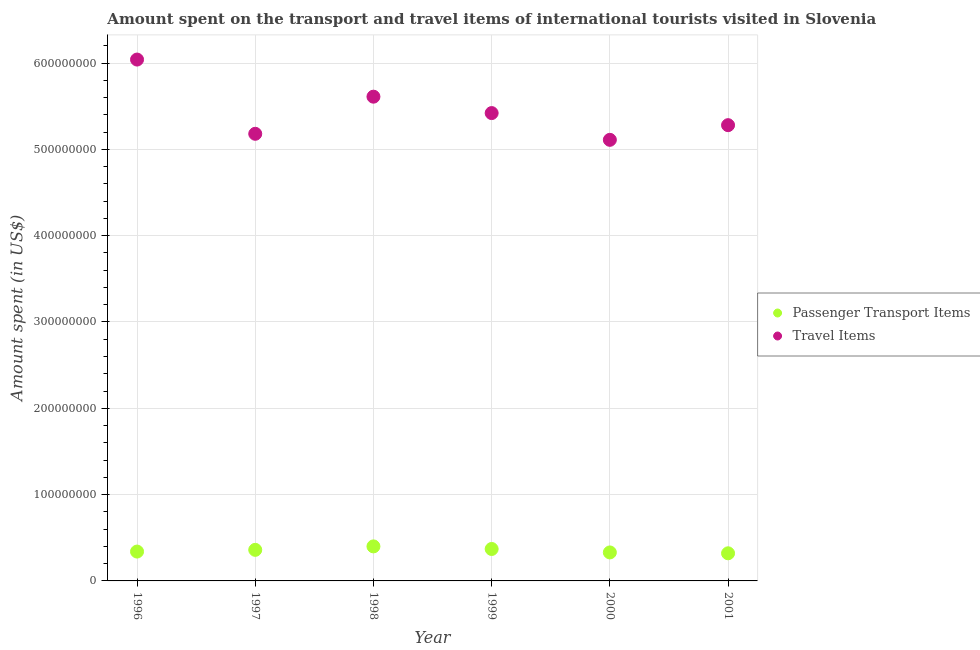How many different coloured dotlines are there?
Give a very brief answer. 2. What is the amount spent on passenger transport items in 1997?
Offer a very short reply. 3.60e+07. Across all years, what is the maximum amount spent on passenger transport items?
Provide a succinct answer. 4.00e+07. Across all years, what is the minimum amount spent in travel items?
Your response must be concise. 5.11e+08. In which year was the amount spent on passenger transport items minimum?
Give a very brief answer. 2001. What is the total amount spent on passenger transport items in the graph?
Offer a very short reply. 2.12e+08. What is the difference between the amount spent on passenger transport items in 1997 and that in 1999?
Give a very brief answer. -1.00e+06. What is the difference between the amount spent on passenger transport items in 2000 and the amount spent in travel items in 1996?
Your answer should be compact. -5.71e+08. What is the average amount spent in travel items per year?
Make the answer very short. 5.44e+08. In the year 1998, what is the difference between the amount spent on passenger transport items and amount spent in travel items?
Ensure brevity in your answer.  -5.21e+08. What is the ratio of the amount spent in travel items in 1999 to that in 2000?
Offer a terse response. 1.06. Is the amount spent in travel items in 1996 less than that in 2001?
Give a very brief answer. No. What is the difference between the highest and the second highest amount spent on passenger transport items?
Provide a succinct answer. 3.00e+06. What is the difference between the highest and the lowest amount spent on passenger transport items?
Provide a succinct answer. 8.00e+06. Is the sum of the amount spent on passenger transport items in 1997 and 1998 greater than the maximum amount spent in travel items across all years?
Keep it short and to the point. No. Is the amount spent in travel items strictly greater than the amount spent on passenger transport items over the years?
Provide a succinct answer. Yes. How many dotlines are there?
Give a very brief answer. 2. How many years are there in the graph?
Provide a short and direct response. 6. Are the values on the major ticks of Y-axis written in scientific E-notation?
Provide a succinct answer. No. Does the graph contain any zero values?
Provide a short and direct response. No. Does the graph contain grids?
Make the answer very short. Yes. Where does the legend appear in the graph?
Keep it short and to the point. Center right. What is the title of the graph?
Provide a short and direct response. Amount spent on the transport and travel items of international tourists visited in Slovenia. What is the label or title of the Y-axis?
Ensure brevity in your answer.  Amount spent (in US$). What is the Amount spent (in US$) in Passenger Transport Items in 1996?
Provide a succinct answer. 3.40e+07. What is the Amount spent (in US$) of Travel Items in 1996?
Provide a succinct answer. 6.04e+08. What is the Amount spent (in US$) of Passenger Transport Items in 1997?
Your answer should be compact. 3.60e+07. What is the Amount spent (in US$) in Travel Items in 1997?
Ensure brevity in your answer.  5.18e+08. What is the Amount spent (in US$) in Passenger Transport Items in 1998?
Make the answer very short. 4.00e+07. What is the Amount spent (in US$) of Travel Items in 1998?
Offer a very short reply. 5.61e+08. What is the Amount spent (in US$) in Passenger Transport Items in 1999?
Ensure brevity in your answer.  3.70e+07. What is the Amount spent (in US$) of Travel Items in 1999?
Give a very brief answer. 5.42e+08. What is the Amount spent (in US$) of Passenger Transport Items in 2000?
Your answer should be compact. 3.30e+07. What is the Amount spent (in US$) of Travel Items in 2000?
Offer a very short reply. 5.11e+08. What is the Amount spent (in US$) in Passenger Transport Items in 2001?
Keep it short and to the point. 3.20e+07. What is the Amount spent (in US$) of Travel Items in 2001?
Provide a succinct answer. 5.28e+08. Across all years, what is the maximum Amount spent (in US$) of Passenger Transport Items?
Make the answer very short. 4.00e+07. Across all years, what is the maximum Amount spent (in US$) in Travel Items?
Ensure brevity in your answer.  6.04e+08. Across all years, what is the minimum Amount spent (in US$) in Passenger Transport Items?
Provide a short and direct response. 3.20e+07. Across all years, what is the minimum Amount spent (in US$) in Travel Items?
Ensure brevity in your answer.  5.11e+08. What is the total Amount spent (in US$) in Passenger Transport Items in the graph?
Your answer should be compact. 2.12e+08. What is the total Amount spent (in US$) in Travel Items in the graph?
Provide a short and direct response. 3.26e+09. What is the difference between the Amount spent (in US$) of Travel Items in 1996 and that in 1997?
Offer a very short reply. 8.60e+07. What is the difference between the Amount spent (in US$) of Passenger Transport Items in 1996 and that in 1998?
Your answer should be compact. -6.00e+06. What is the difference between the Amount spent (in US$) of Travel Items in 1996 and that in 1998?
Your response must be concise. 4.30e+07. What is the difference between the Amount spent (in US$) in Passenger Transport Items in 1996 and that in 1999?
Offer a terse response. -3.00e+06. What is the difference between the Amount spent (in US$) in Travel Items in 1996 and that in 1999?
Your answer should be compact. 6.20e+07. What is the difference between the Amount spent (in US$) in Travel Items in 1996 and that in 2000?
Give a very brief answer. 9.30e+07. What is the difference between the Amount spent (in US$) in Travel Items in 1996 and that in 2001?
Provide a succinct answer. 7.60e+07. What is the difference between the Amount spent (in US$) of Passenger Transport Items in 1997 and that in 1998?
Your response must be concise. -4.00e+06. What is the difference between the Amount spent (in US$) in Travel Items in 1997 and that in 1998?
Provide a succinct answer. -4.30e+07. What is the difference between the Amount spent (in US$) in Travel Items in 1997 and that in 1999?
Make the answer very short. -2.40e+07. What is the difference between the Amount spent (in US$) of Passenger Transport Items in 1997 and that in 2000?
Ensure brevity in your answer.  3.00e+06. What is the difference between the Amount spent (in US$) of Travel Items in 1997 and that in 2000?
Your answer should be very brief. 7.00e+06. What is the difference between the Amount spent (in US$) of Passenger Transport Items in 1997 and that in 2001?
Your answer should be compact. 4.00e+06. What is the difference between the Amount spent (in US$) in Travel Items in 1997 and that in 2001?
Offer a terse response. -1.00e+07. What is the difference between the Amount spent (in US$) in Travel Items in 1998 and that in 1999?
Make the answer very short. 1.90e+07. What is the difference between the Amount spent (in US$) in Passenger Transport Items in 1998 and that in 2000?
Give a very brief answer. 7.00e+06. What is the difference between the Amount spent (in US$) in Travel Items in 1998 and that in 2000?
Give a very brief answer. 5.00e+07. What is the difference between the Amount spent (in US$) of Passenger Transport Items in 1998 and that in 2001?
Make the answer very short. 8.00e+06. What is the difference between the Amount spent (in US$) of Travel Items in 1998 and that in 2001?
Give a very brief answer. 3.30e+07. What is the difference between the Amount spent (in US$) of Travel Items in 1999 and that in 2000?
Ensure brevity in your answer.  3.10e+07. What is the difference between the Amount spent (in US$) in Travel Items in 1999 and that in 2001?
Ensure brevity in your answer.  1.40e+07. What is the difference between the Amount spent (in US$) in Passenger Transport Items in 2000 and that in 2001?
Offer a very short reply. 1.00e+06. What is the difference between the Amount spent (in US$) of Travel Items in 2000 and that in 2001?
Keep it short and to the point. -1.70e+07. What is the difference between the Amount spent (in US$) in Passenger Transport Items in 1996 and the Amount spent (in US$) in Travel Items in 1997?
Keep it short and to the point. -4.84e+08. What is the difference between the Amount spent (in US$) of Passenger Transport Items in 1996 and the Amount spent (in US$) of Travel Items in 1998?
Keep it short and to the point. -5.27e+08. What is the difference between the Amount spent (in US$) of Passenger Transport Items in 1996 and the Amount spent (in US$) of Travel Items in 1999?
Make the answer very short. -5.08e+08. What is the difference between the Amount spent (in US$) of Passenger Transport Items in 1996 and the Amount spent (in US$) of Travel Items in 2000?
Give a very brief answer. -4.77e+08. What is the difference between the Amount spent (in US$) in Passenger Transport Items in 1996 and the Amount spent (in US$) in Travel Items in 2001?
Your response must be concise. -4.94e+08. What is the difference between the Amount spent (in US$) of Passenger Transport Items in 1997 and the Amount spent (in US$) of Travel Items in 1998?
Ensure brevity in your answer.  -5.25e+08. What is the difference between the Amount spent (in US$) of Passenger Transport Items in 1997 and the Amount spent (in US$) of Travel Items in 1999?
Offer a very short reply. -5.06e+08. What is the difference between the Amount spent (in US$) in Passenger Transport Items in 1997 and the Amount spent (in US$) in Travel Items in 2000?
Keep it short and to the point. -4.75e+08. What is the difference between the Amount spent (in US$) of Passenger Transport Items in 1997 and the Amount spent (in US$) of Travel Items in 2001?
Make the answer very short. -4.92e+08. What is the difference between the Amount spent (in US$) of Passenger Transport Items in 1998 and the Amount spent (in US$) of Travel Items in 1999?
Offer a very short reply. -5.02e+08. What is the difference between the Amount spent (in US$) in Passenger Transport Items in 1998 and the Amount spent (in US$) in Travel Items in 2000?
Your response must be concise. -4.71e+08. What is the difference between the Amount spent (in US$) of Passenger Transport Items in 1998 and the Amount spent (in US$) of Travel Items in 2001?
Provide a short and direct response. -4.88e+08. What is the difference between the Amount spent (in US$) in Passenger Transport Items in 1999 and the Amount spent (in US$) in Travel Items in 2000?
Give a very brief answer. -4.74e+08. What is the difference between the Amount spent (in US$) of Passenger Transport Items in 1999 and the Amount spent (in US$) of Travel Items in 2001?
Ensure brevity in your answer.  -4.91e+08. What is the difference between the Amount spent (in US$) of Passenger Transport Items in 2000 and the Amount spent (in US$) of Travel Items in 2001?
Keep it short and to the point. -4.95e+08. What is the average Amount spent (in US$) of Passenger Transport Items per year?
Offer a very short reply. 3.53e+07. What is the average Amount spent (in US$) in Travel Items per year?
Provide a short and direct response. 5.44e+08. In the year 1996, what is the difference between the Amount spent (in US$) in Passenger Transport Items and Amount spent (in US$) in Travel Items?
Keep it short and to the point. -5.70e+08. In the year 1997, what is the difference between the Amount spent (in US$) of Passenger Transport Items and Amount spent (in US$) of Travel Items?
Ensure brevity in your answer.  -4.82e+08. In the year 1998, what is the difference between the Amount spent (in US$) of Passenger Transport Items and Amount spent (in US$) of Travel Items?
Keep it short and to the point. -5.21e+08. In the year 1999, what is the difference between the Amount spent (in US$) of Passenger Transport Items and Amount spent (in US$) of Travel Items?
Provide a short and direct response. -5.05e+08. In the year 2000, what is the difference between the Amount spent (in US$) in Passenger Transport Items and Amount spent (in US$) in Travel Items?
Your answer should be compact. -4.78e+08. In the year 2001, what is the difference between the Amount spent (in US$) of Passenger Transport Items and Amount spent (in US$) of Travel Items?
Provide a short and direct response. -4.96e+08. What is the ratio of the Amount spent (in US$) in Passenger Transport Items in 1996 to that in 1997?
Your answer should be compact. 0.94. What is the ratio of the Amount spent (in US$) in Travel Items in 1996 to that in 1997?
Offer a very short reply. 1.17. What is the ratio of the Amount spent (in US$) of Passenger Transport Items in 1996 to that in 1998?
Your answer should be compact. 0.85. What is the ratio of the Amount spent (in US$) of Travel Items in 1996 to that in 1998?
Your response must be concise. 1.08. What is the ratio of the Amount spent (in US$) in Passenger Transport Items in 1996 to that in 1999?
Offer a very short reply. 0.92. What is the ratio of the Amount spent (in US$) in Travel Items in 1996 to that in 1999?
Ensure brevity in your answer.  1.11. What is the ratio of the Amount spent (in US$) of Passenger Transport Items in 1996 to that in 2000?
Provide a short and direct response. 1.03. What is the ratio of the Amount spent (in US$) of Travel Items in 1996 to that in 2000?
Your response must be concise. 1.18. What is the ratio of the Amount spent (in US$) of Travel Items in 1996 to that in 2001?
Offer a terse response. 1.14. What is the ratio of the Amount spent (in US$) in Travel Items in 1997 to that in 1998?
Provide a succinct answer. 0.92. What is the ratio of the Amount spent (in US$) of Passenger Transport Items in 1997 to that in 1999?
Provide a short and direct response. 0.97. What is the ratio of the Amount spent (in US$) in Travel Items in 1997 to that in 1999?
Provide a succinct answer. 0.96. What is the ratio of the Amount spent (in US$) in Travel Items in 1997 to that in 2000?
Your answer should be compact. 1.01. What is the ratio of the Amount spent (in US$) in Travel Items in 1997 to that in 2001?
Offer a very short reply. 0.98. What is the ratio of the Amount spent (in US$) in Passenger Transport Items in 1998 to that in 1999?
Keep it short and to the point. 1.08. What is the ratio of the Amount spent (in US$) of Travel Items in 1998 to that in 1999?
Offer a terse response. 1.04. What is the ratio of the Amount spent (in US$) of Passenger Transport Items in 1998 to that in 2000?
Give a very brief answer. 1.21. What is the ratio of the Amount spent (in US$) of Travel Items in 1998 to that in 2000?
Your answer should be compact. 1.1. What is the ratio of the Amount spent (in US$) in Passenger Transport Items in 1998 to that in 2001?
Offer a terse response. 1.25. What is the ratio of the Amount spent (in US$) in Passenger Transport Items in 1999 to that in 2000?
Ensure brevity in your answer.  1.12. What is the ratio of the Amount spent (in US$) in Travel Items in 1999 to that in 2000?
Your response must be concise. 1.06. What is the ratio of the Amount spent (in US$) of Passenger Transport Items in 1999 to that in 2001?
Ensure brevity in your answer.  1.16. What is the ratio of the Amount spent (in US$) in Travel Items in 1999 to that in 2001?
Ensure brevity in your answer.  1.03. What is the ratio of the Amount spent (in US$) of Passenger Transport Items in 2000 to that in 2001?
Provide a short and direct response. 1.03. What is the ratio of the Amount spent (in US$) of Travel Items in 2000 to that in 2001?
Your answer should be compact. 0.97. What is the difference between the highest and the second highest Amount spent (in US$) in Travel Items?
Your answer should be very brief. 4.30e+07. What is the difference between the highest and the lowest Amount spent (in US$) of Travel Items?
Keep it short and to the point. 9.30e+07. 